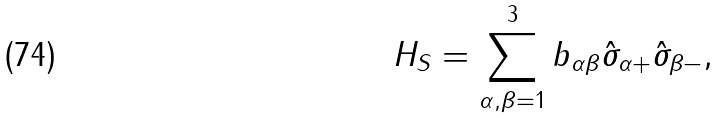Convert formula to latex. <formula><loc_0><loc_0><loc_500><loc_500>H _ { S } = \sum _ { \alpha , \beta = 1 } ^ { 3 } b _ { \alpha \beta } \hat { \sigma } _ { \alpha + } \hat { \sigma } _ { \beta - } ,</formula> 